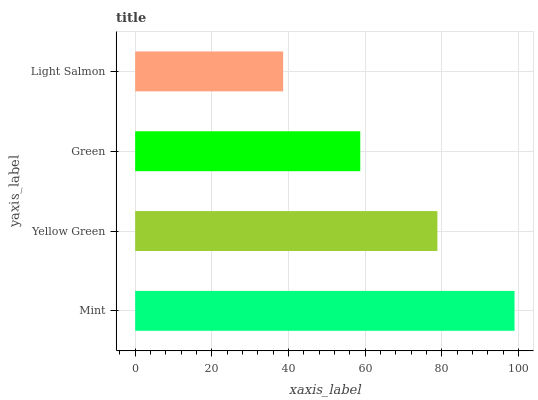Is Light Salmon the minimum?
Answer yes or no. Yes. Is Mint the maximum?
Answer yes or no. Yes. Is Yellow Green the minimum?
Answer yes or no. No. Is Yellow Green the maximum?
Answer yes or no. No. Is Mint greater than Yellow Green?
Answer yes or no. Yes. Is Yellow Green less than Mint?
Answer yes or no. Yes. Is Yellow Green greater than Mint?
Answer yes or no. No. Is Mint less than Yellow Green?
Answer yes or no. No. Is Yellow Green the high median?
Answer yes or no. Yes. Is Green the low median?
Answer yes or no. Yes. Is Light Salmon the high median?
Answer yes or no. No. Is Yellow Green the low median?
Answer yes or no. No. 